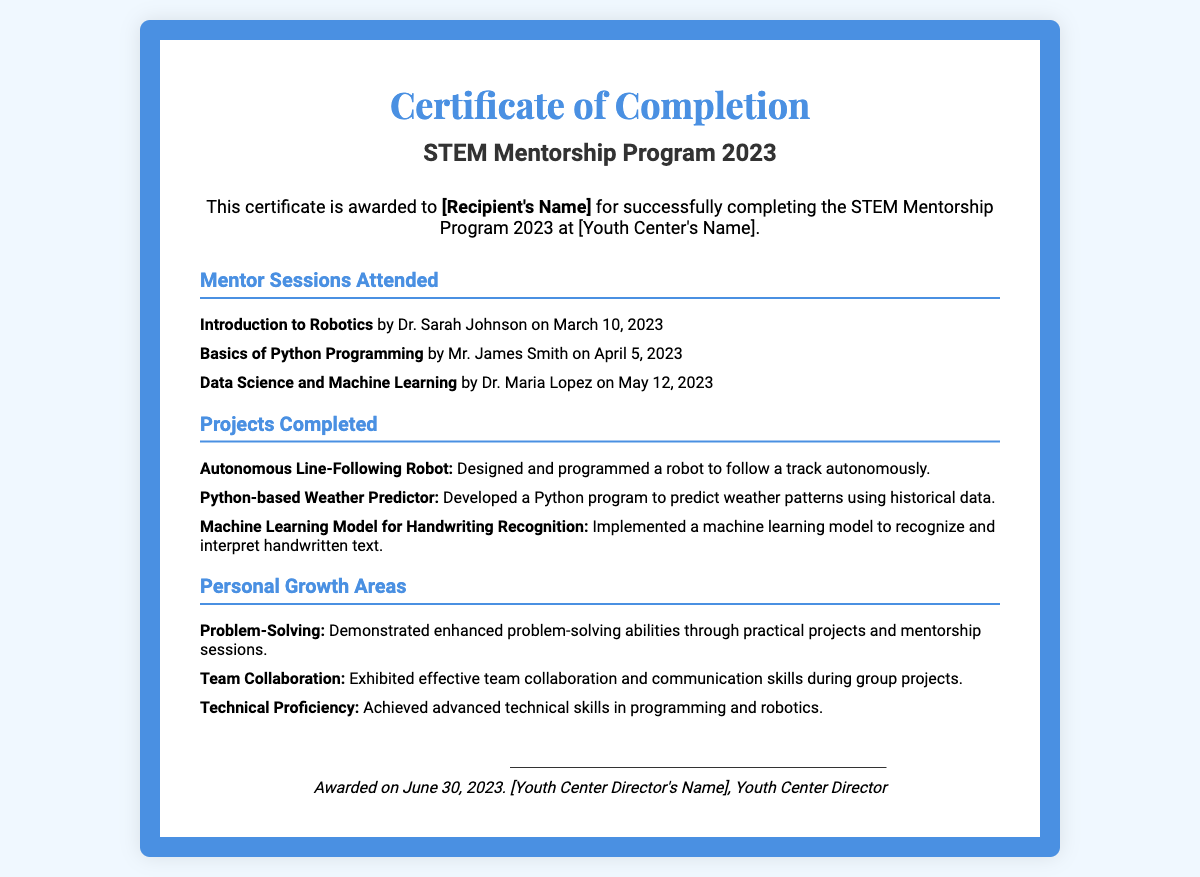What is the name of the program? The name of the program is stated in the title of the certificate.
Answer: STEM Mentorship Program 2023 Who is the recipient of the certificate? The recipient's name is indicated in the certificate text.
Answer: [Recipient's Name] What date was the certificate awarded? The award date is mentioned in the footer of the document.
Answer: June 30, 2023 How many mentor sessions did the recipient attend? The count of mentor sessions is derived from the listed sessions.
Answer: 3 What is one project completed by the recipient? The projects completed section contains multiple project titles.
Answer: Autonomous Line-Following Robot Who taught the "Data Science and Machine Learning" session? The mentor's name is provided with the session title in the document.
Answer: Dr. Maria Lopez What skill area was improved through practical projects? This is found under the personal growth areas section of the certificate.
Answer: Problem-Solving What is the color of the border on the certificate? The certificate's styling specifies the border color.
Answer: #4a90e2 What type of document is this? The document serves a specific purpose and indicates completion.
Answer: Certificate of Completion 